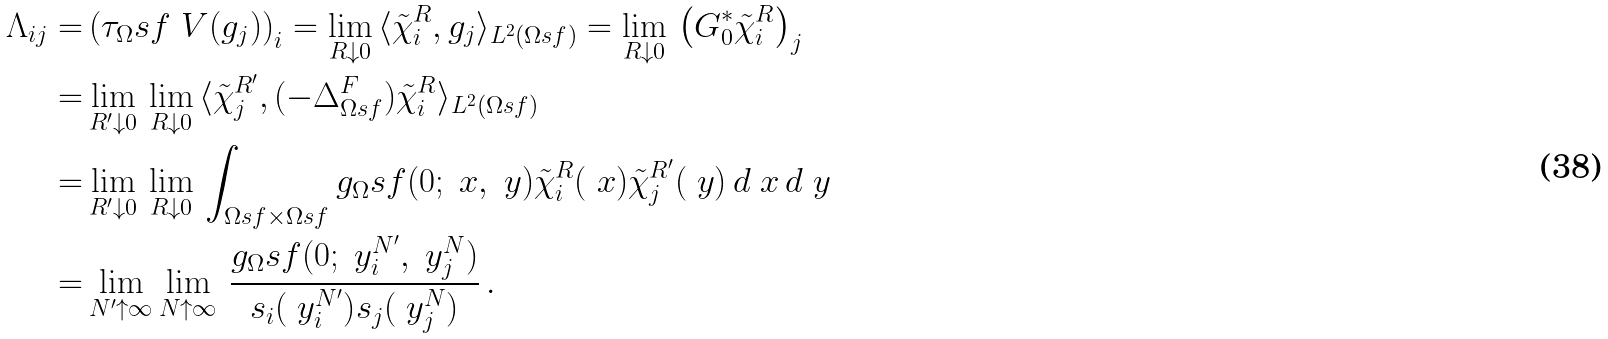<formula> <loc_0><loc_0><loc_500><loc_500>\Lambda _ { i j } = & \left ( \tau _ { \Omega } s f ^ { \ } V ( g _ { j } ) \right ) _ { i } = \lim _ { R \downarrow 0 } \, \langle \tilde { \chi } _ { i } ^ { R } , g _ { j } \rangle _ { L ^ { 2 } ( \Omega s f ) } = \lim _ { R \downarrow 0 } \, \left ( G _ { 0 } ^ { * } \tilde { \chi } _ { i } ^ { R } \right ) _ { j } \\ = & \lim _ { R ^ { \prime } \downarrow 0 } \, \lim _ { R \downarrow 0 } \, \langle \tilde { \chi } _ { j } ^ { R ^ { \prime } } , ( - \Delta ^ { F } _ { \Omega s f } ) \tilde { \chi } _ { i } ^ { R } \rangle _ { L ^ { 2 } ( \Omega s f ) } \\ = & \lim _ { R ^ { \prime } \downarrow 0 } \, \lim _ { R \downarrow 0 } \, \int _ { \Omega s f \times \Omega s f } g _ { \Omega } s f ( 0 ; \ x , \ y ) \tilde { \chi } ^ { R } _ { i } ( \ x ) \tilde { \chi } ^ { R ^ { \prime } } _ { j } ( \ y ) \, d \ x \, d \ y \\ = & \lim _ { N ^ { \prime } \uparrow \infty } \lim _ { N \uparrow \infty } \, \frac { g _ { \Omega } s f ( 0 ; \ y ^ { N ^ { \prime } } _ { i } , \ y ^ { N } _ { j } ) } { { s _ { i } ( \ y _ { i } ^ { N ^ { \prime } } ) } { s _ { j } ( \ y _ { j } ^ { N } ) } } \, .</formula> 